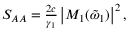Convert formula to latex. <formula><loc_0><loc_0><loc_500><loc_500>\begin{array} { r } { S _ { A A } = \frac { 2 c } { \gamma _ { 1 } } \left | M _ { 1 } ( \tilde { \omega } _ { 1 } ) \right | ^ { 2 } , } \end{array}</formula> 